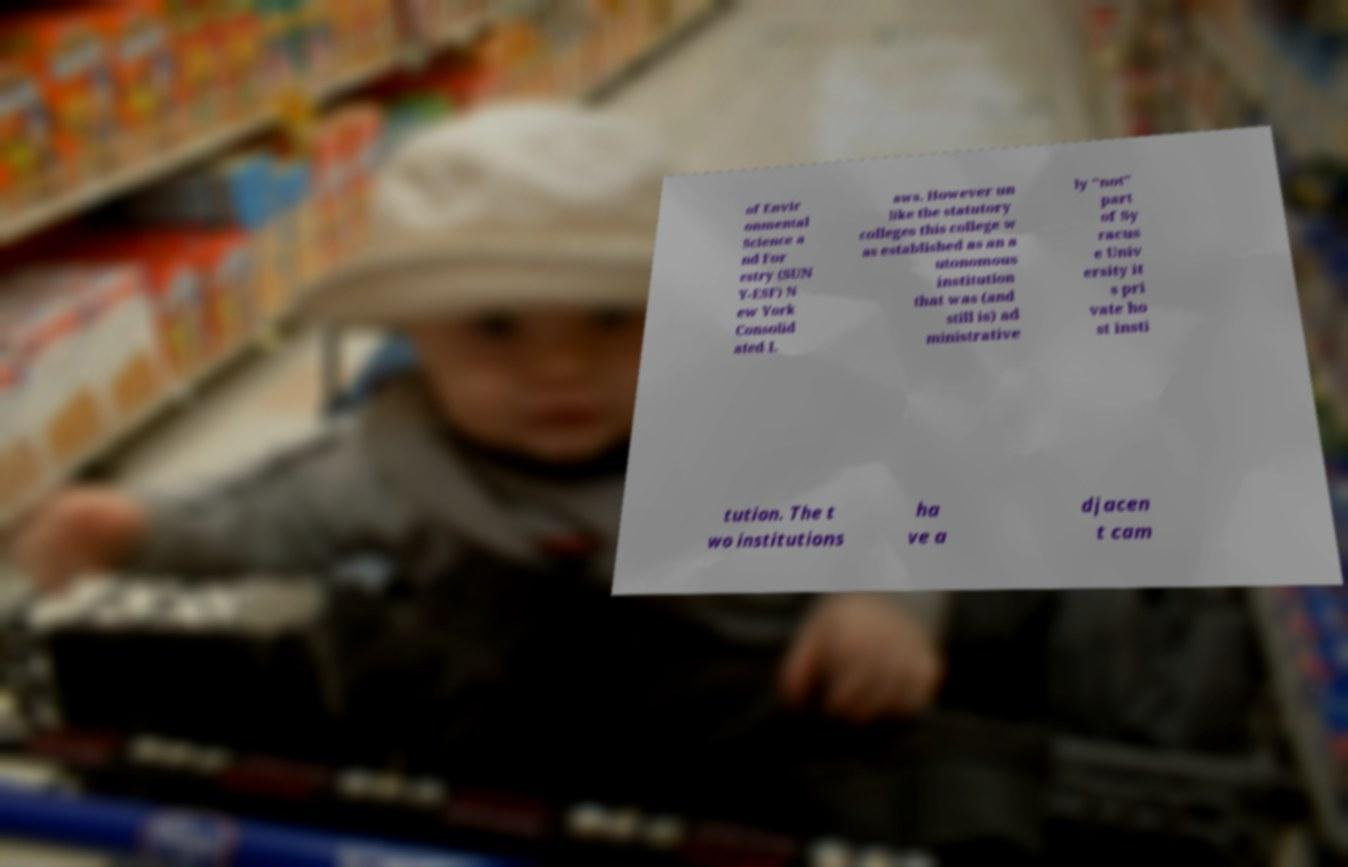Could you assist in decoding the text presented in this image and type it out clearly? of Envir onmental Science a nd For estry (SUN Y-ESF) N ew York Consolid ated L aws. However un like the statutory colleges this college w as established as an a utonomous institution that was (and still is) ad ministrative ly "not" part of Sy racus e Univ ersity it s pri vate ho st insti tution. The t wo institutions ha ve a djacen t cam 